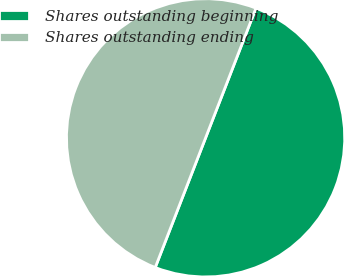Convert chart. <chart><loc_0><loc_0><loc_500><loc_500><pie_chart><fcel>Shares outstanding beginning<fcel>Shares outstanding ending<nl><fcel>50.0%<fcel>50.0%<nl></chart> 